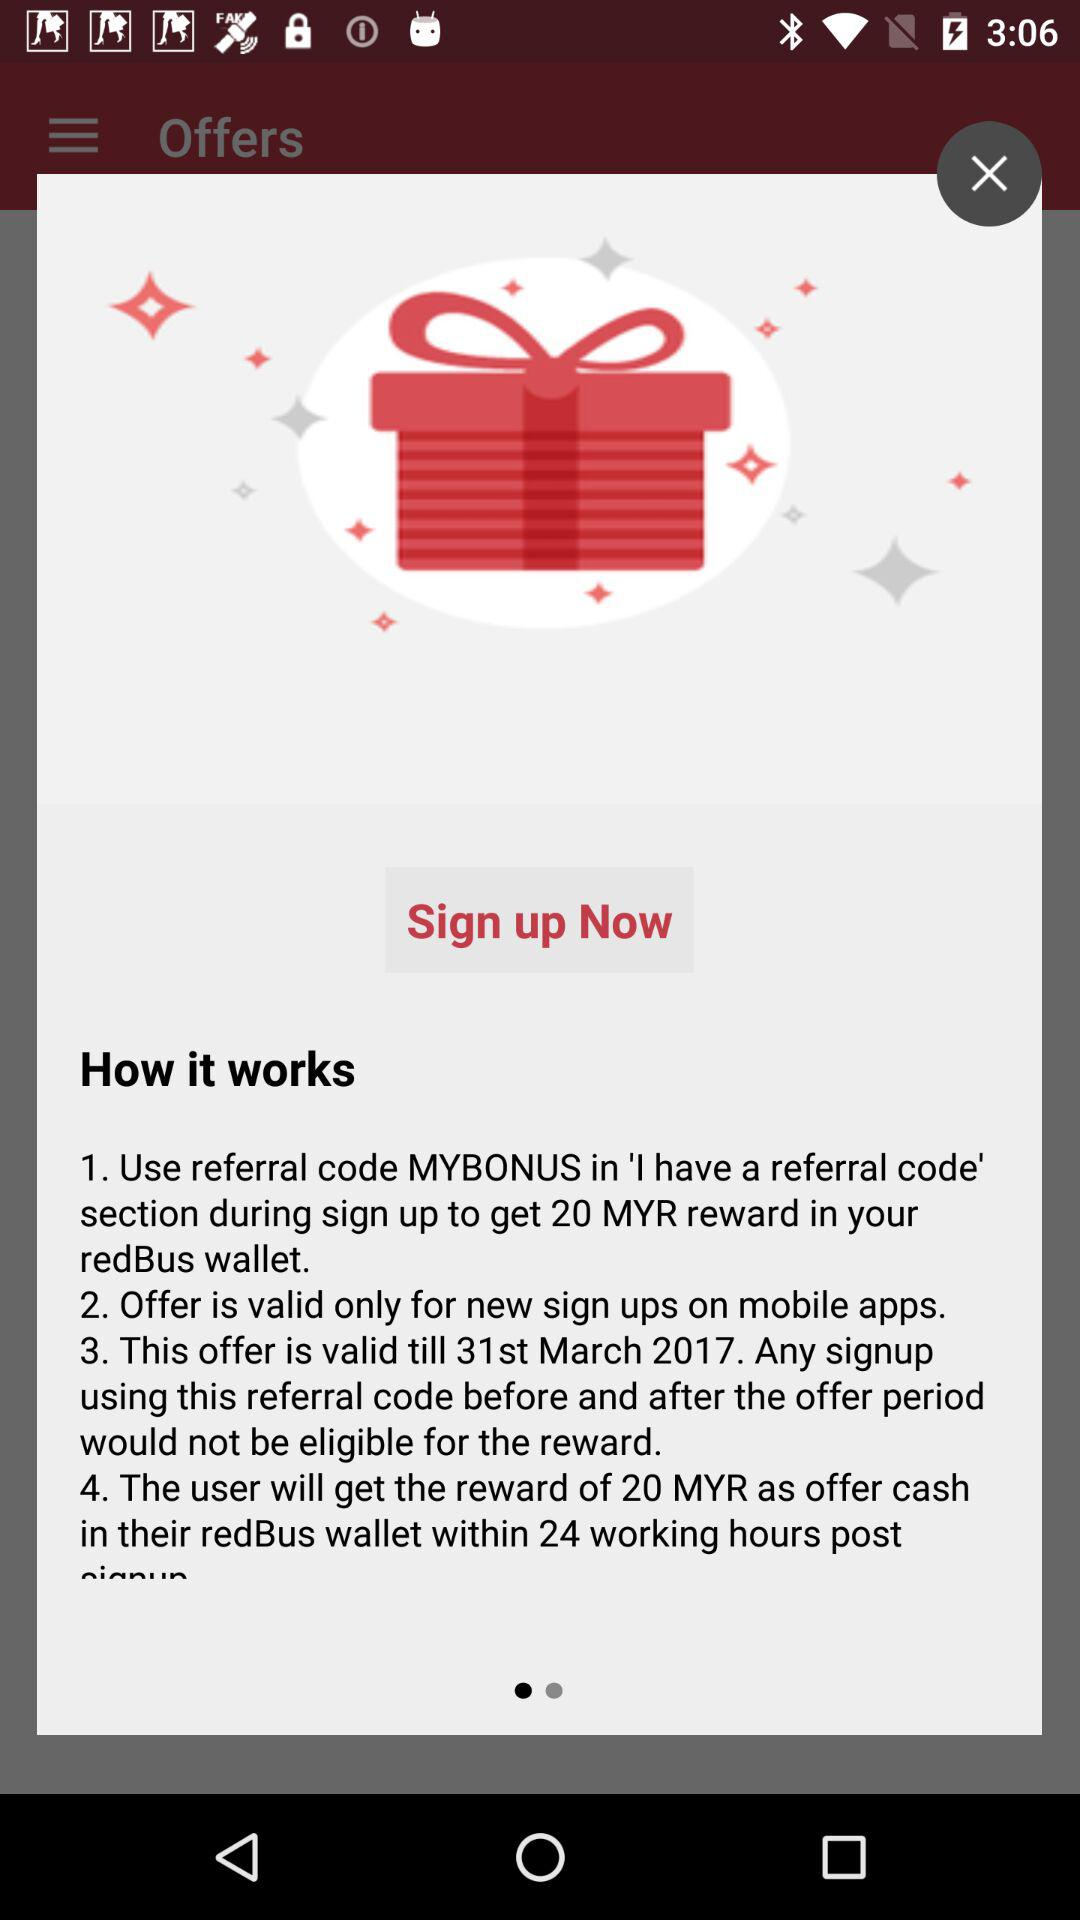How many MYR is the reward for signing up using the referral code?
Answer the question using a single word or phrase. 20 